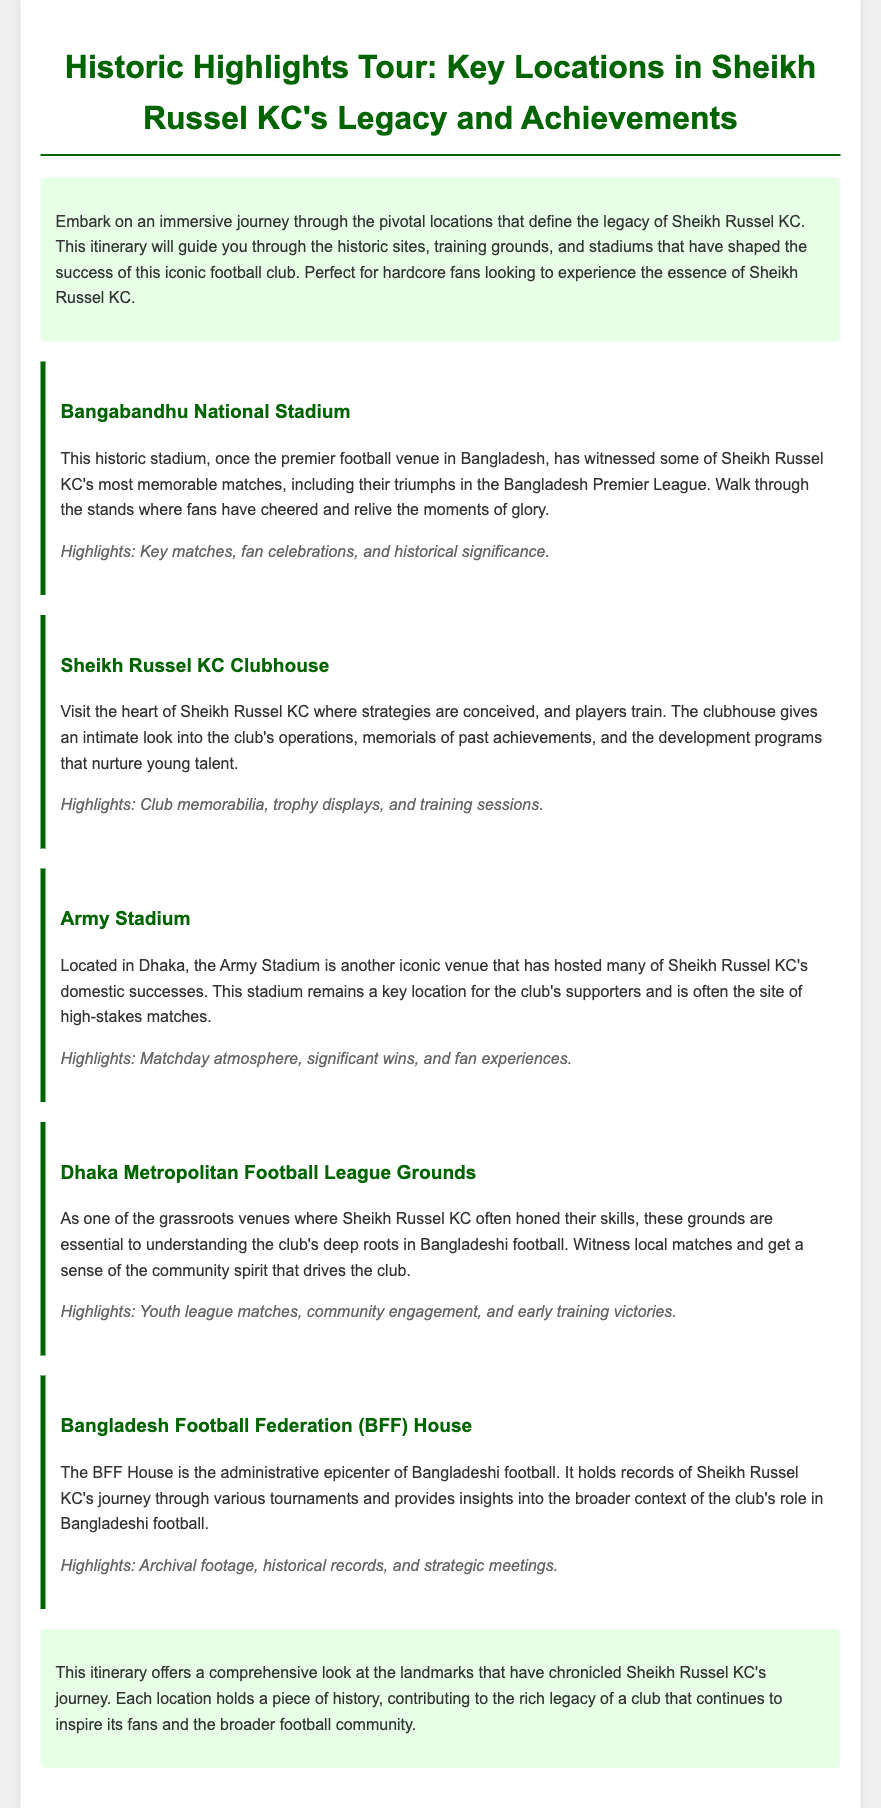What is the title of the document? The title is presented in the header of the document.
Answer: Historic Highlights Tour: Key Locations in Sheikh Russel KC's Legacy and Achievements What is the first location mentioned in the itinerary? The first location is listed as the first itinerary item.
Answer: Bangabandhu National Stadium What significant matches are associated with the Bangabandhu National Stadium? The document states this stadium witnessed some key moments for the club.
Answer: Triumphs in the Bangladesh Premier League Which stadium is located in Dhaka and is significant to Sheikh Russel KC? The document specifies the location and its importance in the context of the club.
Answer: Army Stadium What type of memorabilia can be found at the Sheikh Russel KC Clubhouse? The clubhouse is mentioned to have specific types of items.
Answer: Club memorabilia What is the function of the Bangladesh Football Federation (BFF) House? The document describes the role of this house in relation to Bangladeshi football.
Answer: Administrative epicenter Which location emphasizes community engagement in football? The document indicates a specific location associated with grassroots activities.
Answer: Dhaka Metropolitan Football League Grounds What tone does the conclusion of the itinerary take? The conclusion summarizes the overall sentiment towards Sheikh Russel KC's legacy.
Answer: Comprehensive look 